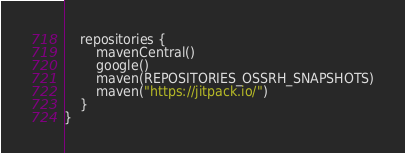Convert code to text. <code><loc_0><loc_0><loc_500><loc_500><_Kotlin_>    repositories {
        mavenCentral()
        google()
        maven(REPOSITORIES_OSSRH_SNAPSHOTS)
        maven("https://jitpack.io/")
    }
}
</code> 